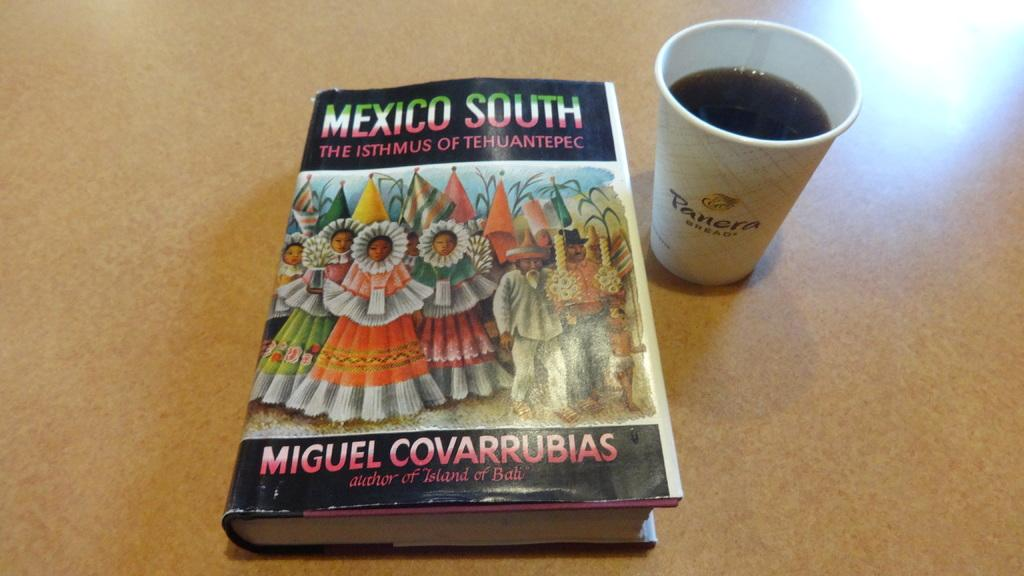<image>
Render a clear and concise summary of the photo. A textbook titled Mexico South the Isthmus of Tehuantepec. 